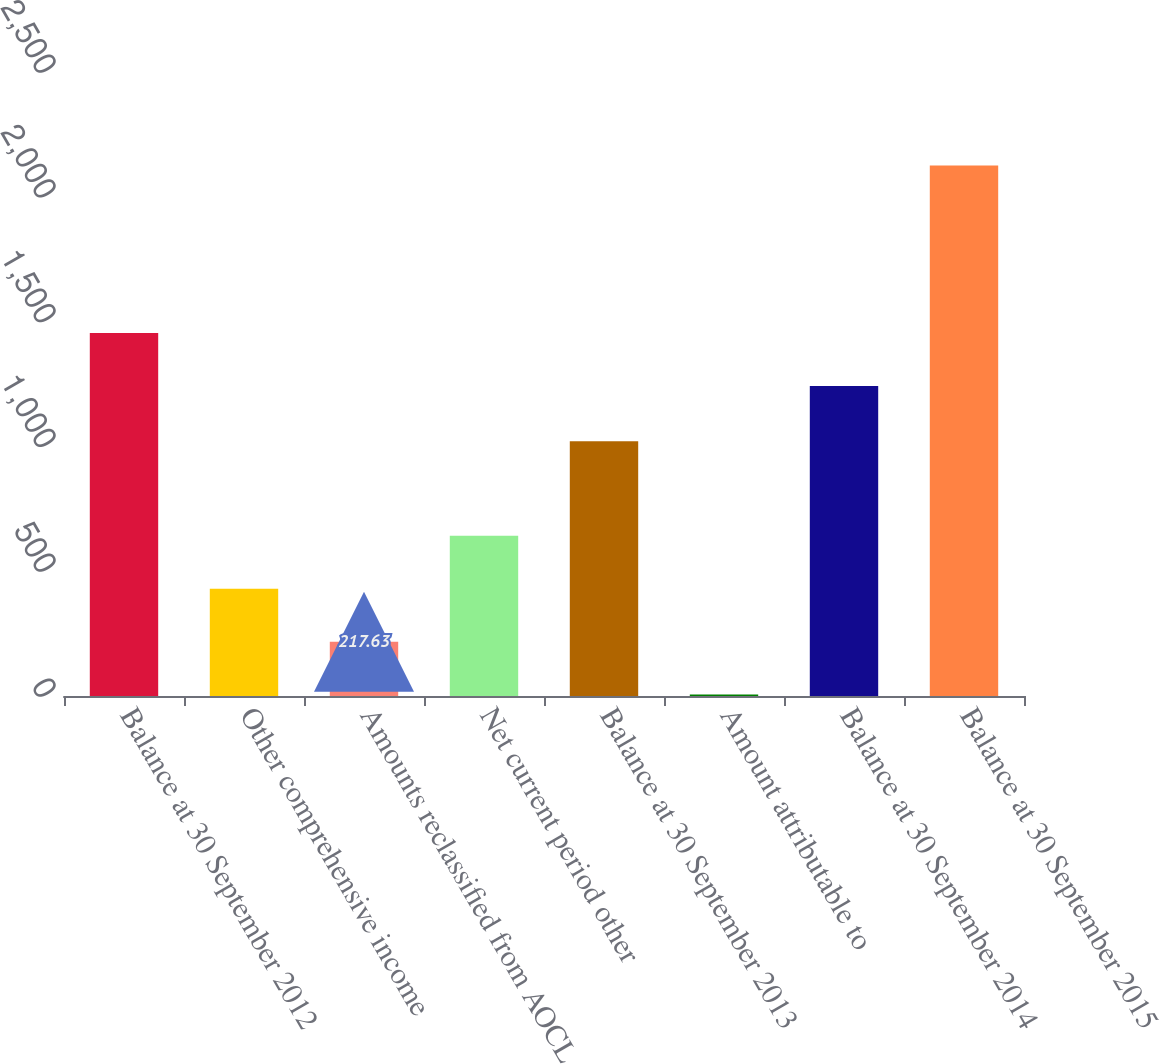<chart> <loc_0><loc_0><loc_500><loc_500><bar_chart><fcel>Balance at 30 September 2012<fcel>Other comprehensive income<fcel>Amounts reclassified from AOCL<fcel>Net current period other<fcel>Balance at 30 September 2013<fcel>Amount attributable to<fcel>Balance at 30 September 2014<fcel>Balance at 30 September 2015<nl><fcel>1453.93<fcel>429.66<fcel>217.63<fcel>641.69<fcel>1020.6<fcel>5.6<fcel>1241.9<fcel>2125.9<nl></chart> 